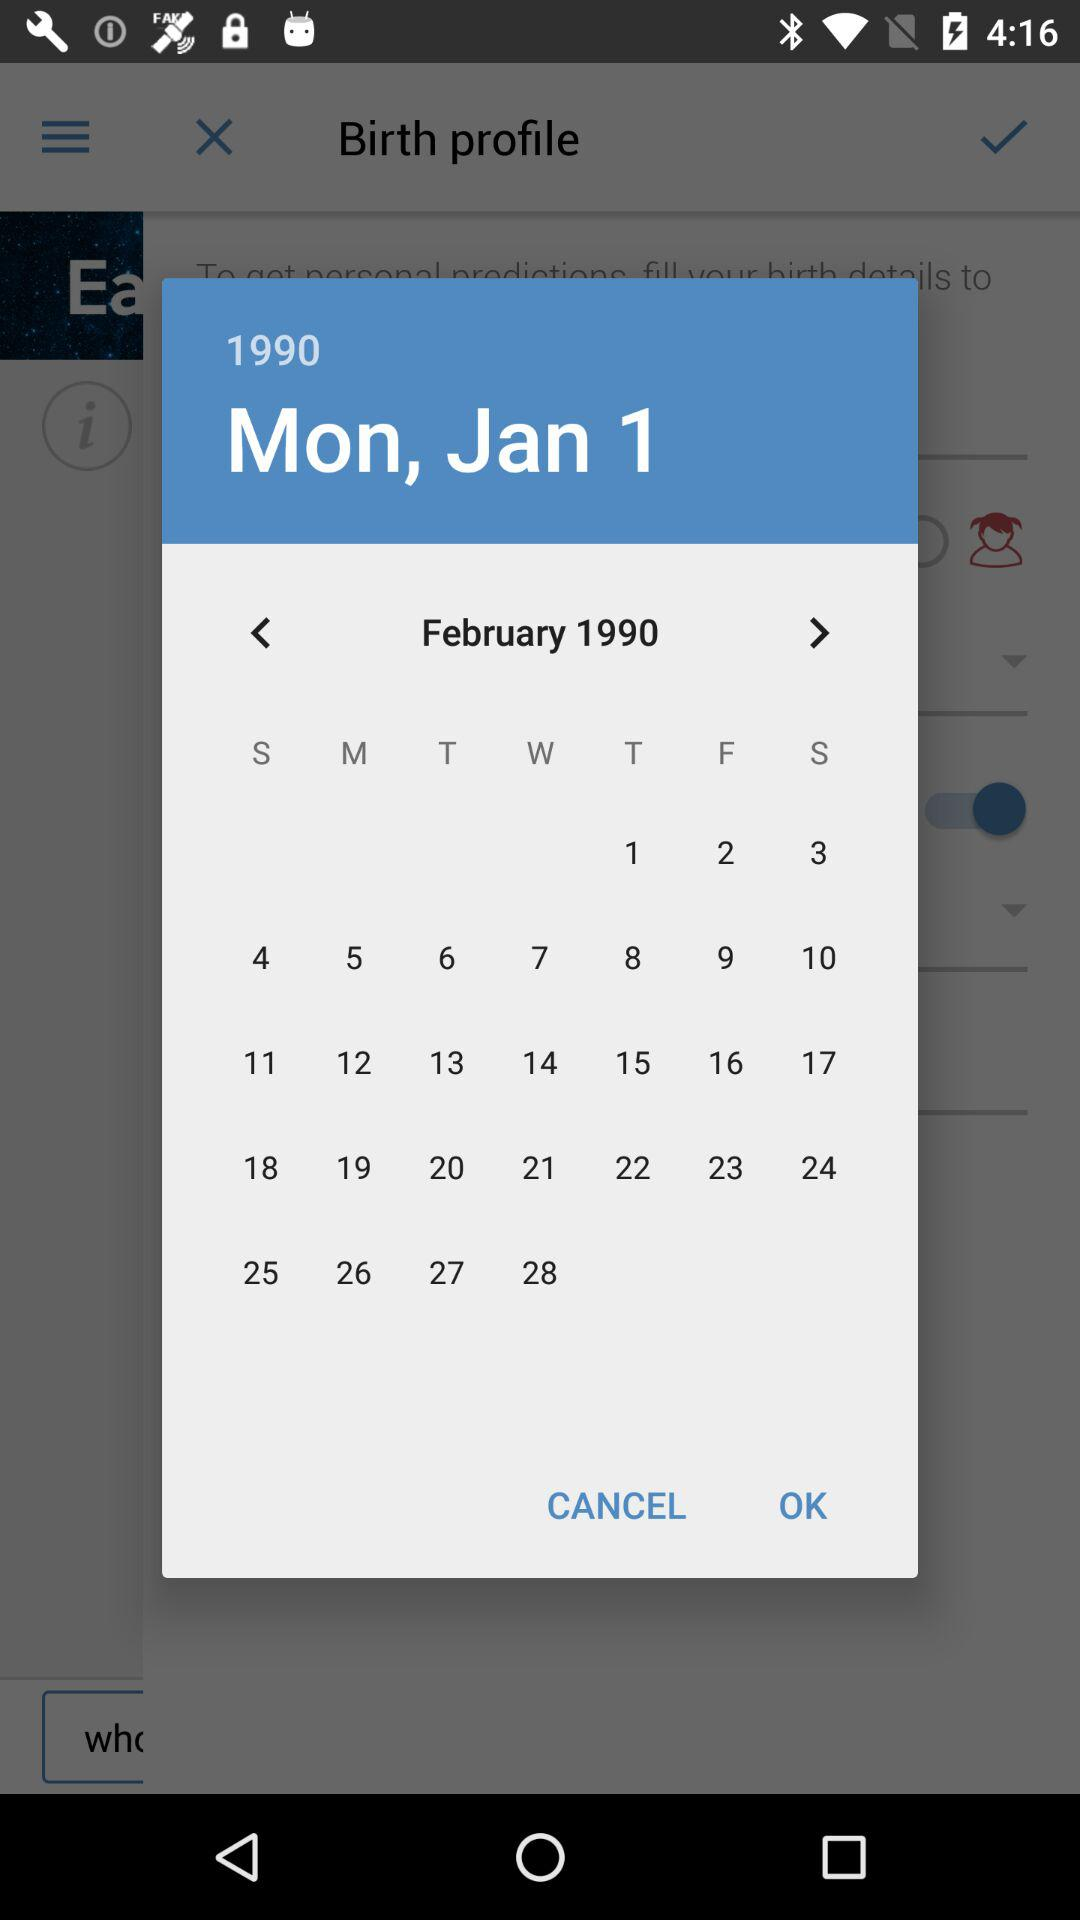What is the day of the given date? The day is Monday. 